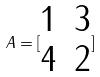<formula> <loc_0><loc_0><loc_500><loc_500>A = [ \begin{matrix} 1 & 3 \\ 4 & 2 \end{matrix} ]</formula> 